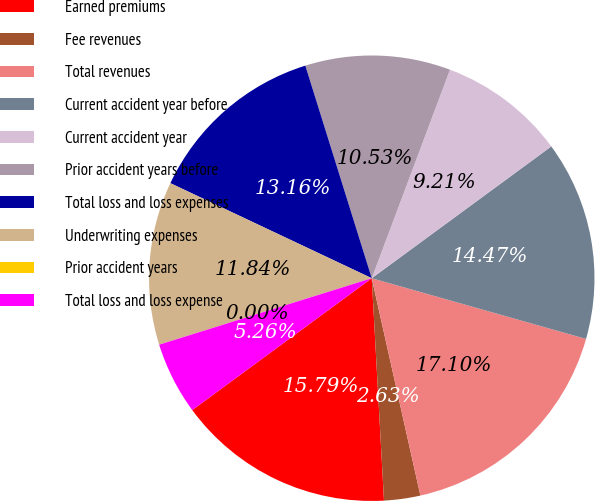<chart> <loc_0><loc_0><loc_500><loc_500><pie_chart><fcel>Earned premiums<fcel>Fee revenues<fcel>Total revenues<fcel>Current accident year before<fcel>Current accident year<fcel>Prior accident years before<fcel>Total loss and loss expenses<fcel>Underwriting expenses<fcel>Prior accident years<fcel>Total loss and loss expense<nl><fcel>15.79%<fcel>2.63%<fcel>17.1%<fcel>14.47%<fcel>9.21%<fcel>10.53%<fcel>13.16%<fcel>11.84%<fcel>0.0%<fcel>5.26%<nl></chart> 